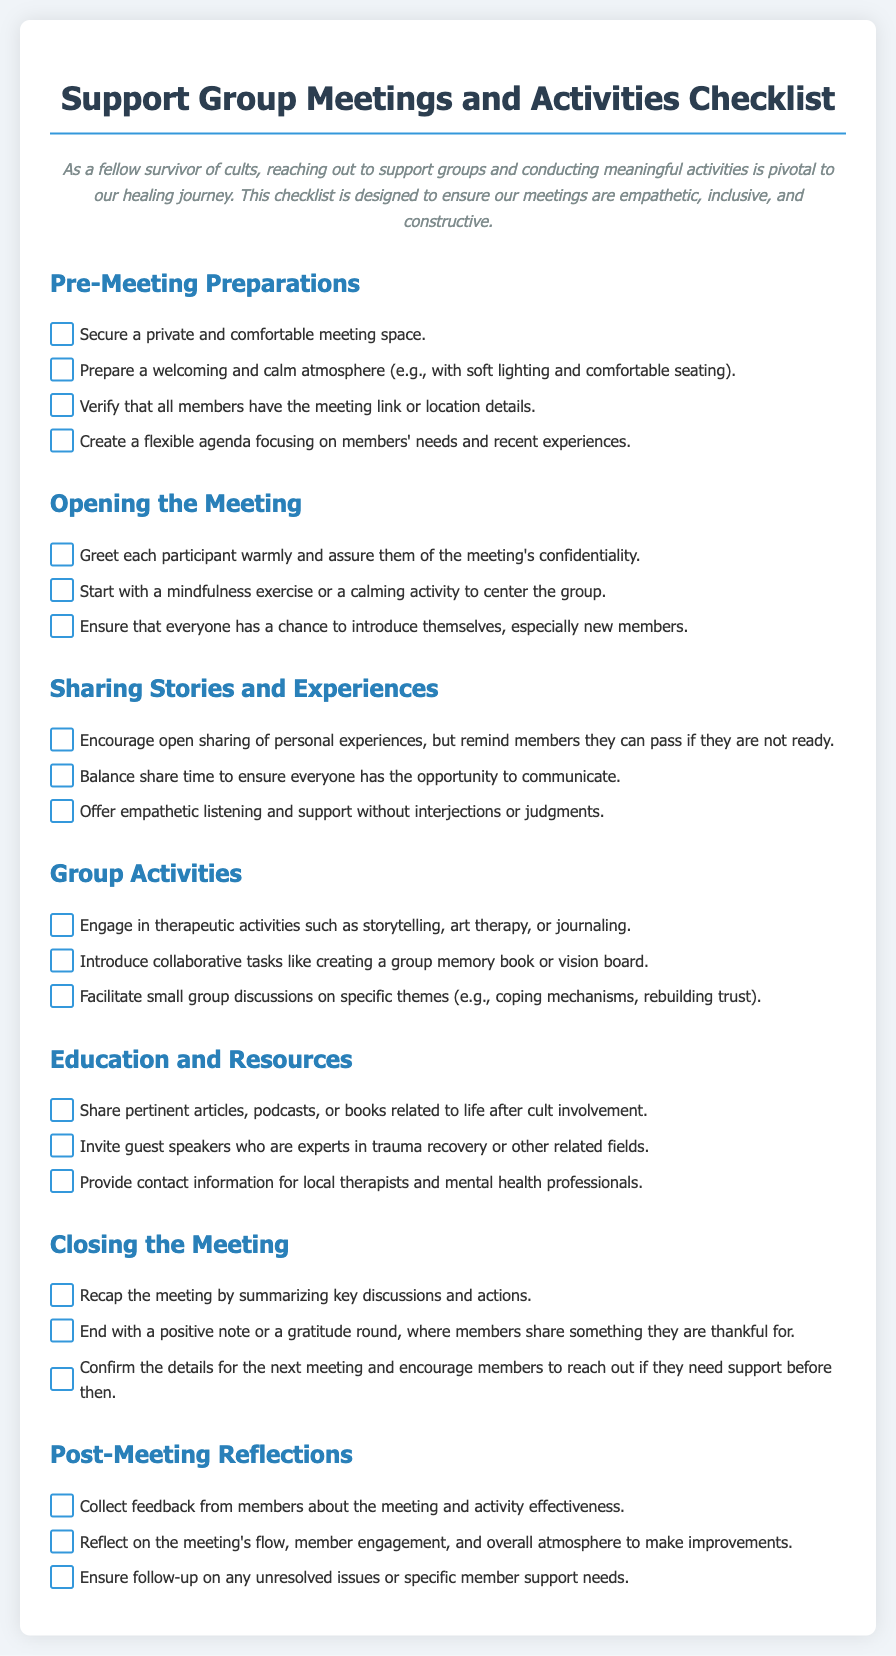what is the title of the document? The title is specified in the document's header section.
Answer: Support Group Meetings and Activities Checklist how many sections are there in the checklist? The number of sections can be counted from the headings present in the document.
Answer: 6 what is the first item in the Pre-Meeting Preparations section? The first item can be identified from the list under the Pre-Meeting Preparations heading.
Answer: Secure a private and comfortable meeting space what type of exercise is suggested to start the meeting? This can be found in the opening section regarding the start of the meeting.
Answer: Mindfulness exercise what is the purpose of the gratitude round in the Closing the Meeting section? The purpose can be inferred from the context of concluding the meeting positively.
Answer: End with a positive note how should feedback from members be collected post-meeting? This can be found under the Post-Meeting Reflections section where feedback is mentioned.
Answer: Collect feedback from members what type of activities are encouraged in the Group Activities section? The emphasis on engaging in different specified activities is outlined in this section.
Answer: Therapeutic activities who can be invited as guest speakers according to the Education and Resources section? This detail can be retrieved from the specified suggestions in the document.
Answer: Experts in trauma recovery 